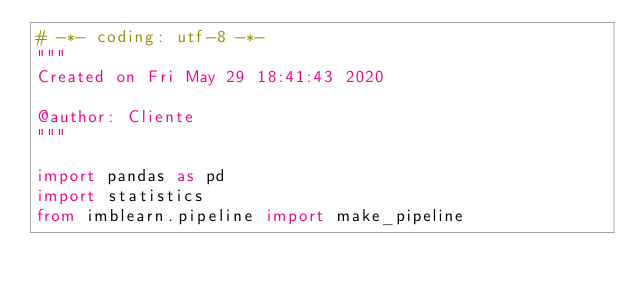Convert code to text. <code><loc_0><loc_0><loc_500><loc_500><_Python_># -*- coding: utf-8 -*-
"""
Created on Fri May 29 18:41:43 2020

@author: Cliente
"""

import pandas as pd
import statistics
from imblearn.pipeline import make_pipeline</code> 